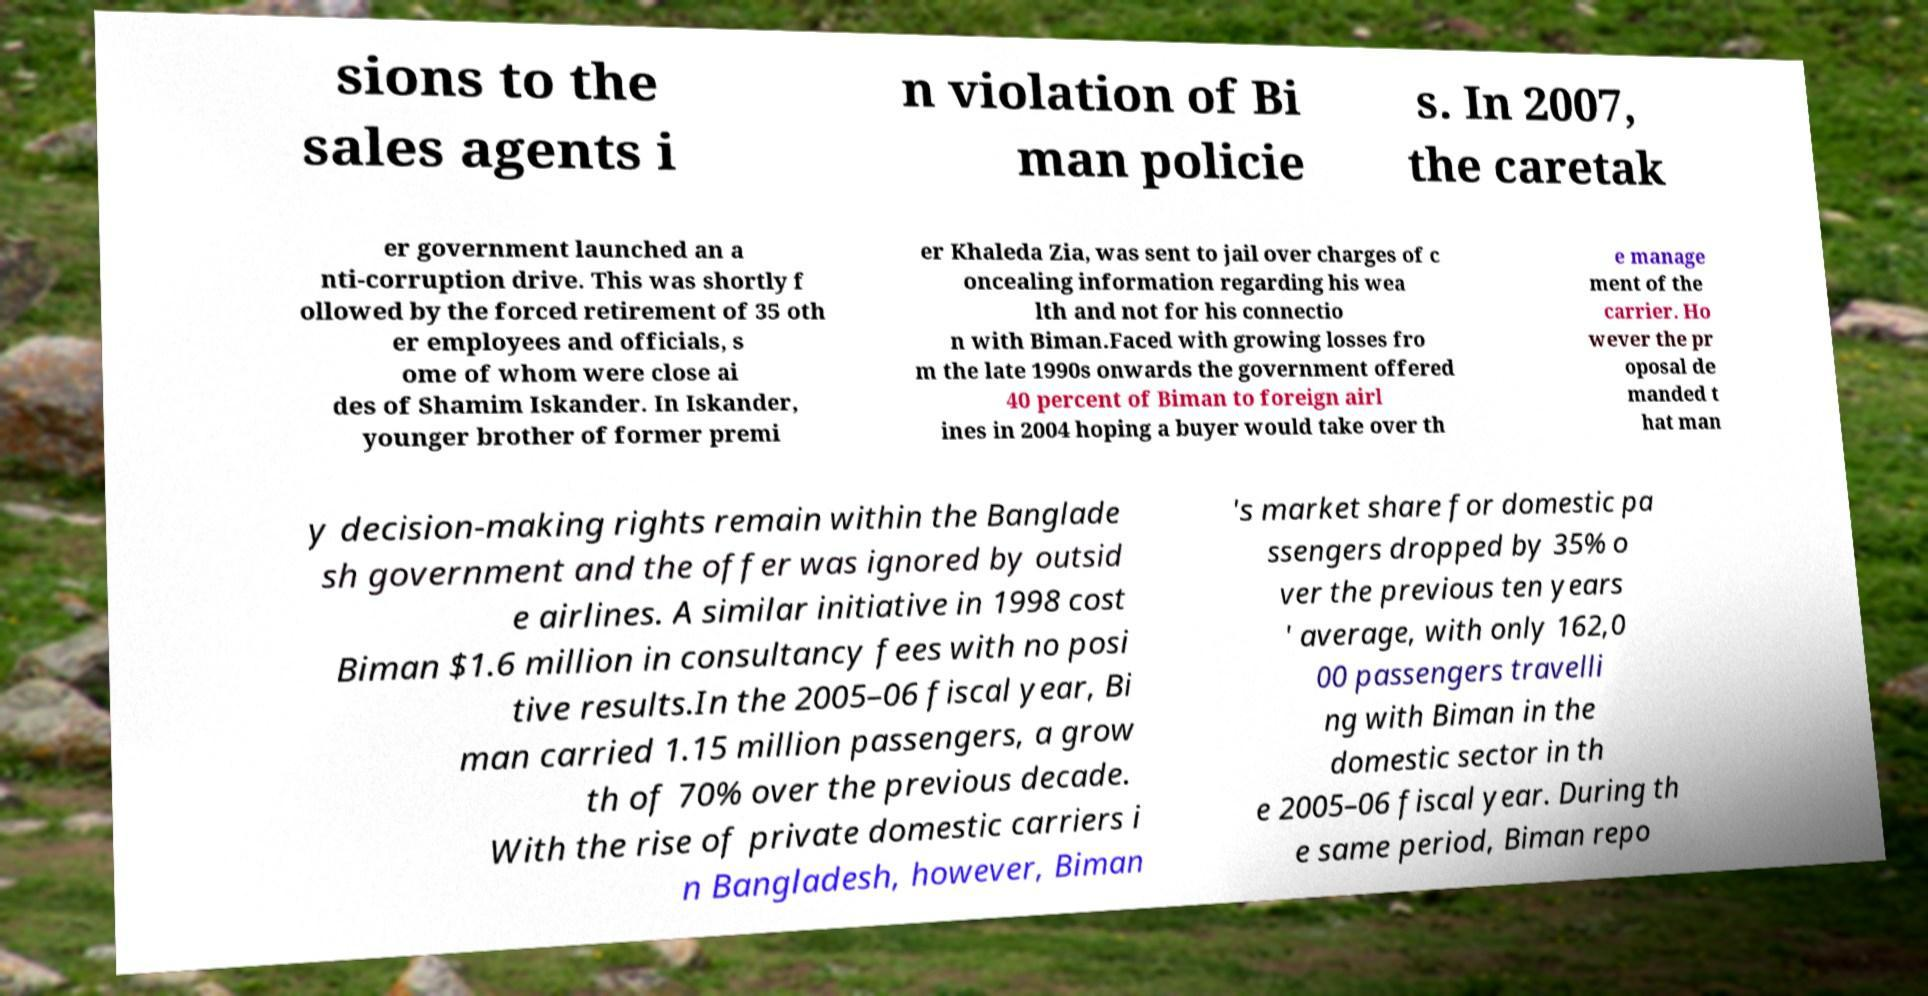Can you accurately transcribe the text from the provided image for me? sions to the sales agents i n violation of Bi man policie s. In 2007, the caretak er government launched an a nti-corruption drive. This was shortly f ollowed by the forced retirement of 35 oth er employees and officials, s ome of whom were close ai des of Shamim Iskander. In Iskander, younger brother of former premi er Khaleda Zia, was sent to jail over charges of c oncealing information regarding his wea lth and not for his connectio n with Biman.Faced with growing losses fro m the late 1990s onwards the government offered 40 percent of Biman to foreign airl ines in 2004 hoping a buyer would take over th e manage ment of the carrier. Ho wever the pr oposal de manded t hat man y decision-making rights remain within the Banglade sh government and the offer was ignored by outsid e airlines. A similar initiative in 1998 cost Biman $1.6 million in consultancy fees with no posi tive results.In the 2005–06 fiscal year, Bi man carried 1.15 million passengers, a grow th of 70% over the previous decade. With the rise of private domestic carriers i n Bangladesh, however, Biman 's market share for domestic pa ssengers dropped by 35% o ver the previous ten years ' average, with only 162,0 00 passengers travelli ng with Biman in the domestic sector in th e 2005–06 fiscal year. During th e same period, Biman repo 